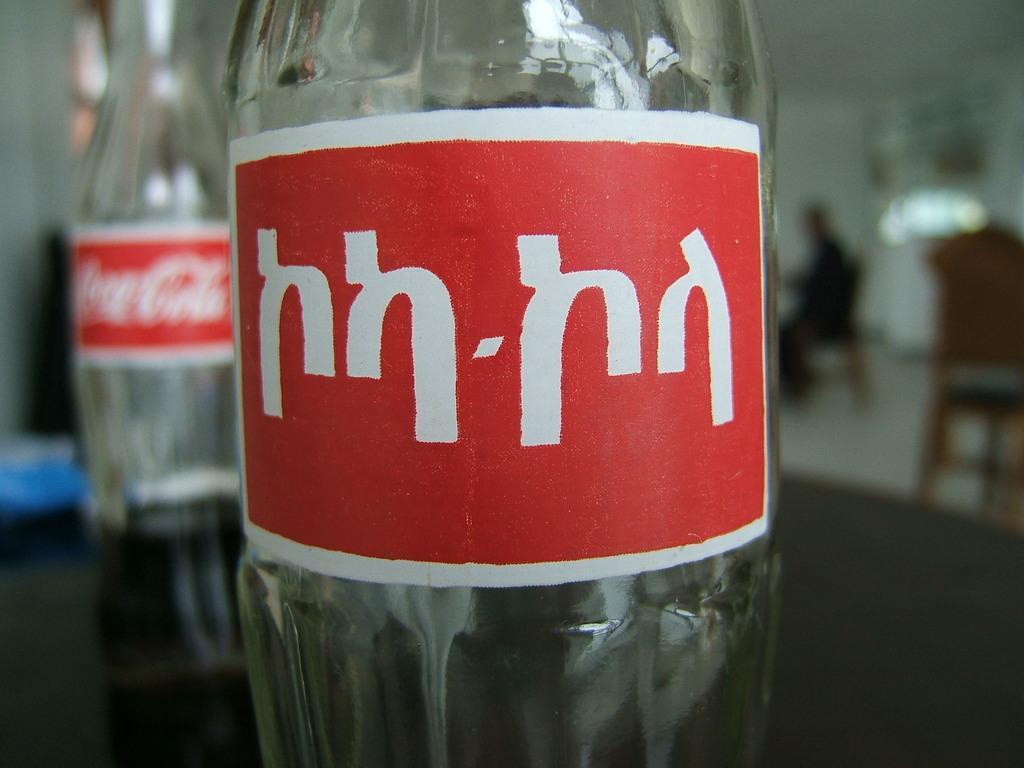Can you describe this image briefly? In this image I can see a glass bottle. On the bottle there is a red color label attached to the bottle and something written on it. At the background we can see a person sitting on the chair. 